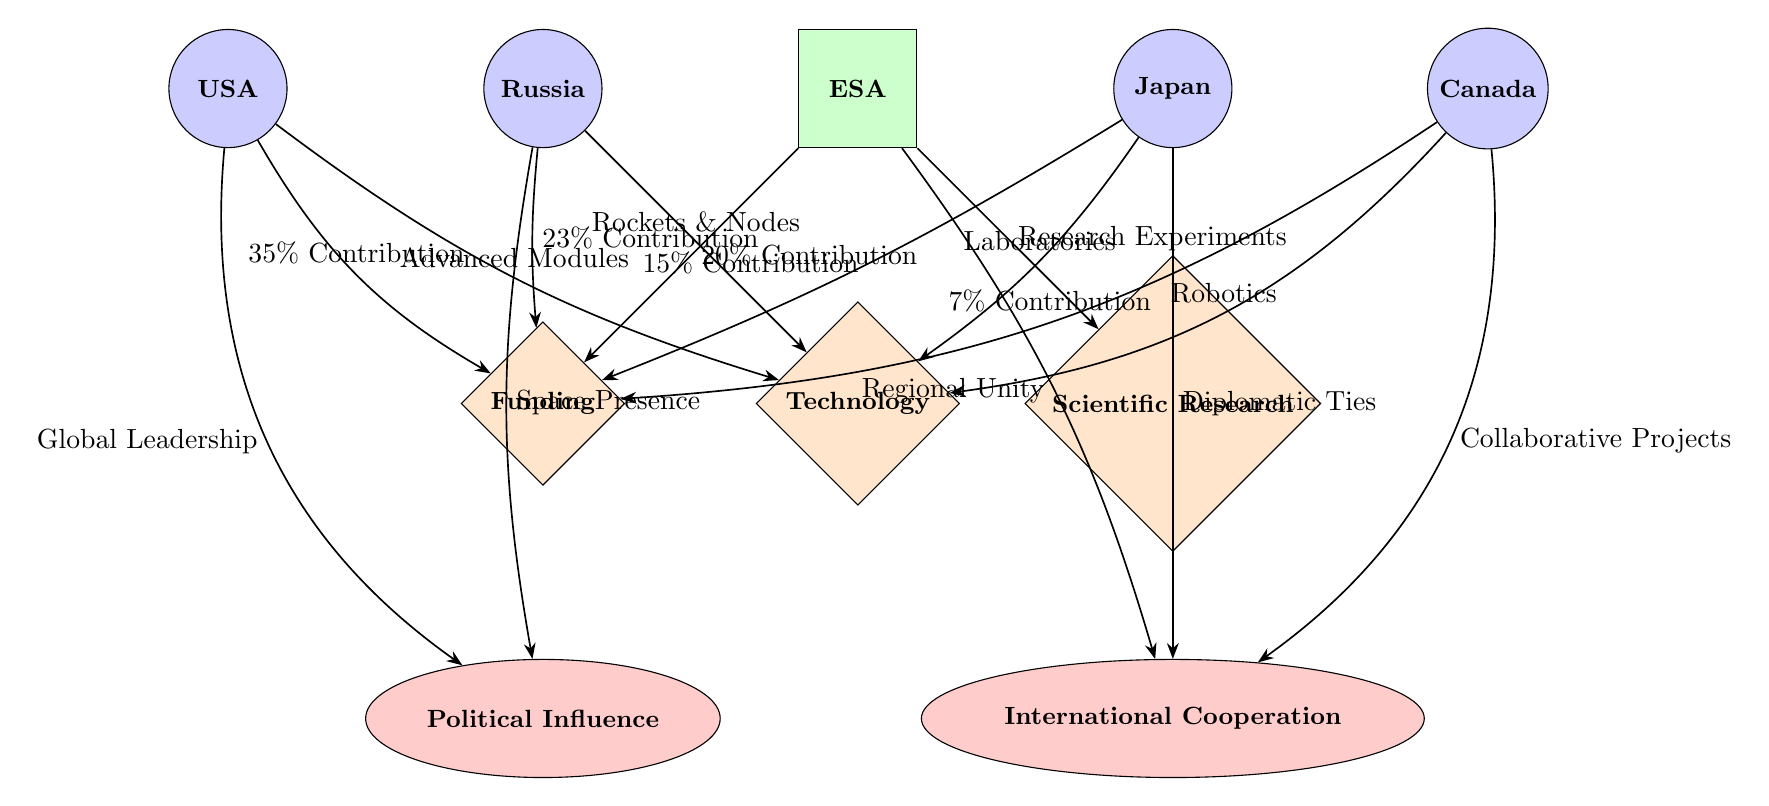What is the contribution percentage of the USA? The diagram shows that the USA contributes 35% to the International Space Station.
Answer: 35% Which country is associated with "Diplomatic Ties"? The diagram indicates that Japan is the country connected with "Diplomatic Ties" under the motive of "International Cooperation".
Answer: Japan How many total countries are represented in the diagram? The diagram features five country nodes: USA, Russia, Japan, Canada, and includes the organization ESA. Thus, counting the countries only, there are four.
Answer: 5 What type of contribution is associated with Canada? The diagram illustrates that Canada is associated with "Robotics" under the "Technology" contribution category.
Answer: Robotics Which motive is linked to the state of "Space Presence"? According to the diagram, "Space Presence" is the motive associated with Russia, under the category of "Political Influence".
Answer: Political Influence How does ESA contribute to the International Space Station? The diagram shows that ESA contributes through "Research Experiments" and represents 20% of the funding.
Answer: Research Experiments Which country has the least contribution percentage? The diagram clearly indicates that Canada has the least contribution percentage at 7%.
Answer: 7% What are the two political motivations represented in the diagram? The diagram indicates that the two political motivations are "Political Influence" and "International Cooperation".
Answer: Political Influence, International Cooperation Which country provides "Advanced Modules" for the ISS? The diagram shows that the USA is responsible for providing "Advanced Modules" under the "Technology" contribution category.
Answer: USA 